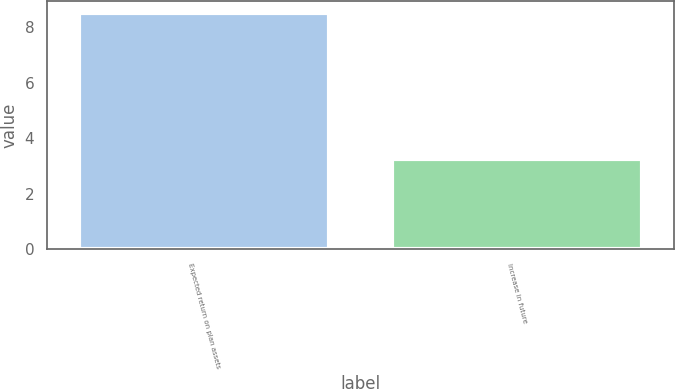Convert chart. <chart><loc_0><loc_0><loc_500><loc_500><bar_chart><fcel>Expected return on plan assets<fcel>Increase in future<nl><fcel>8.5<fcel>3.25<nl></chart> 